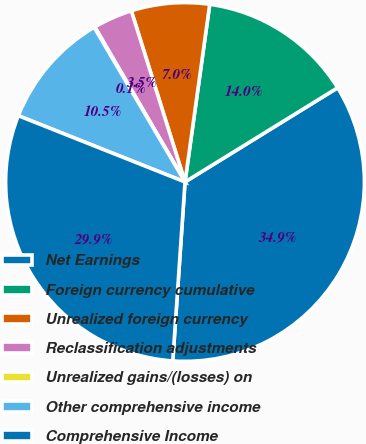<chart> <loc_0><loc_0><loc_500><loc_500><pie_chart><fcel>Net Earnings<fcel>Foreign currency cumulative<fcel>Unrealized foreign currency<fcel>Reclassification adjustments<fcel>Unrealized gains/(losses) on<fcel>Other comprehensive income<fcel>Comprehensive Income<nl><fcel>34.89%<fcel>14.0%<fcel>7.04%<fcel>3.55%<fcel>0.07%<fcel>10.52%<fcel>29.94%<nl></chart> 